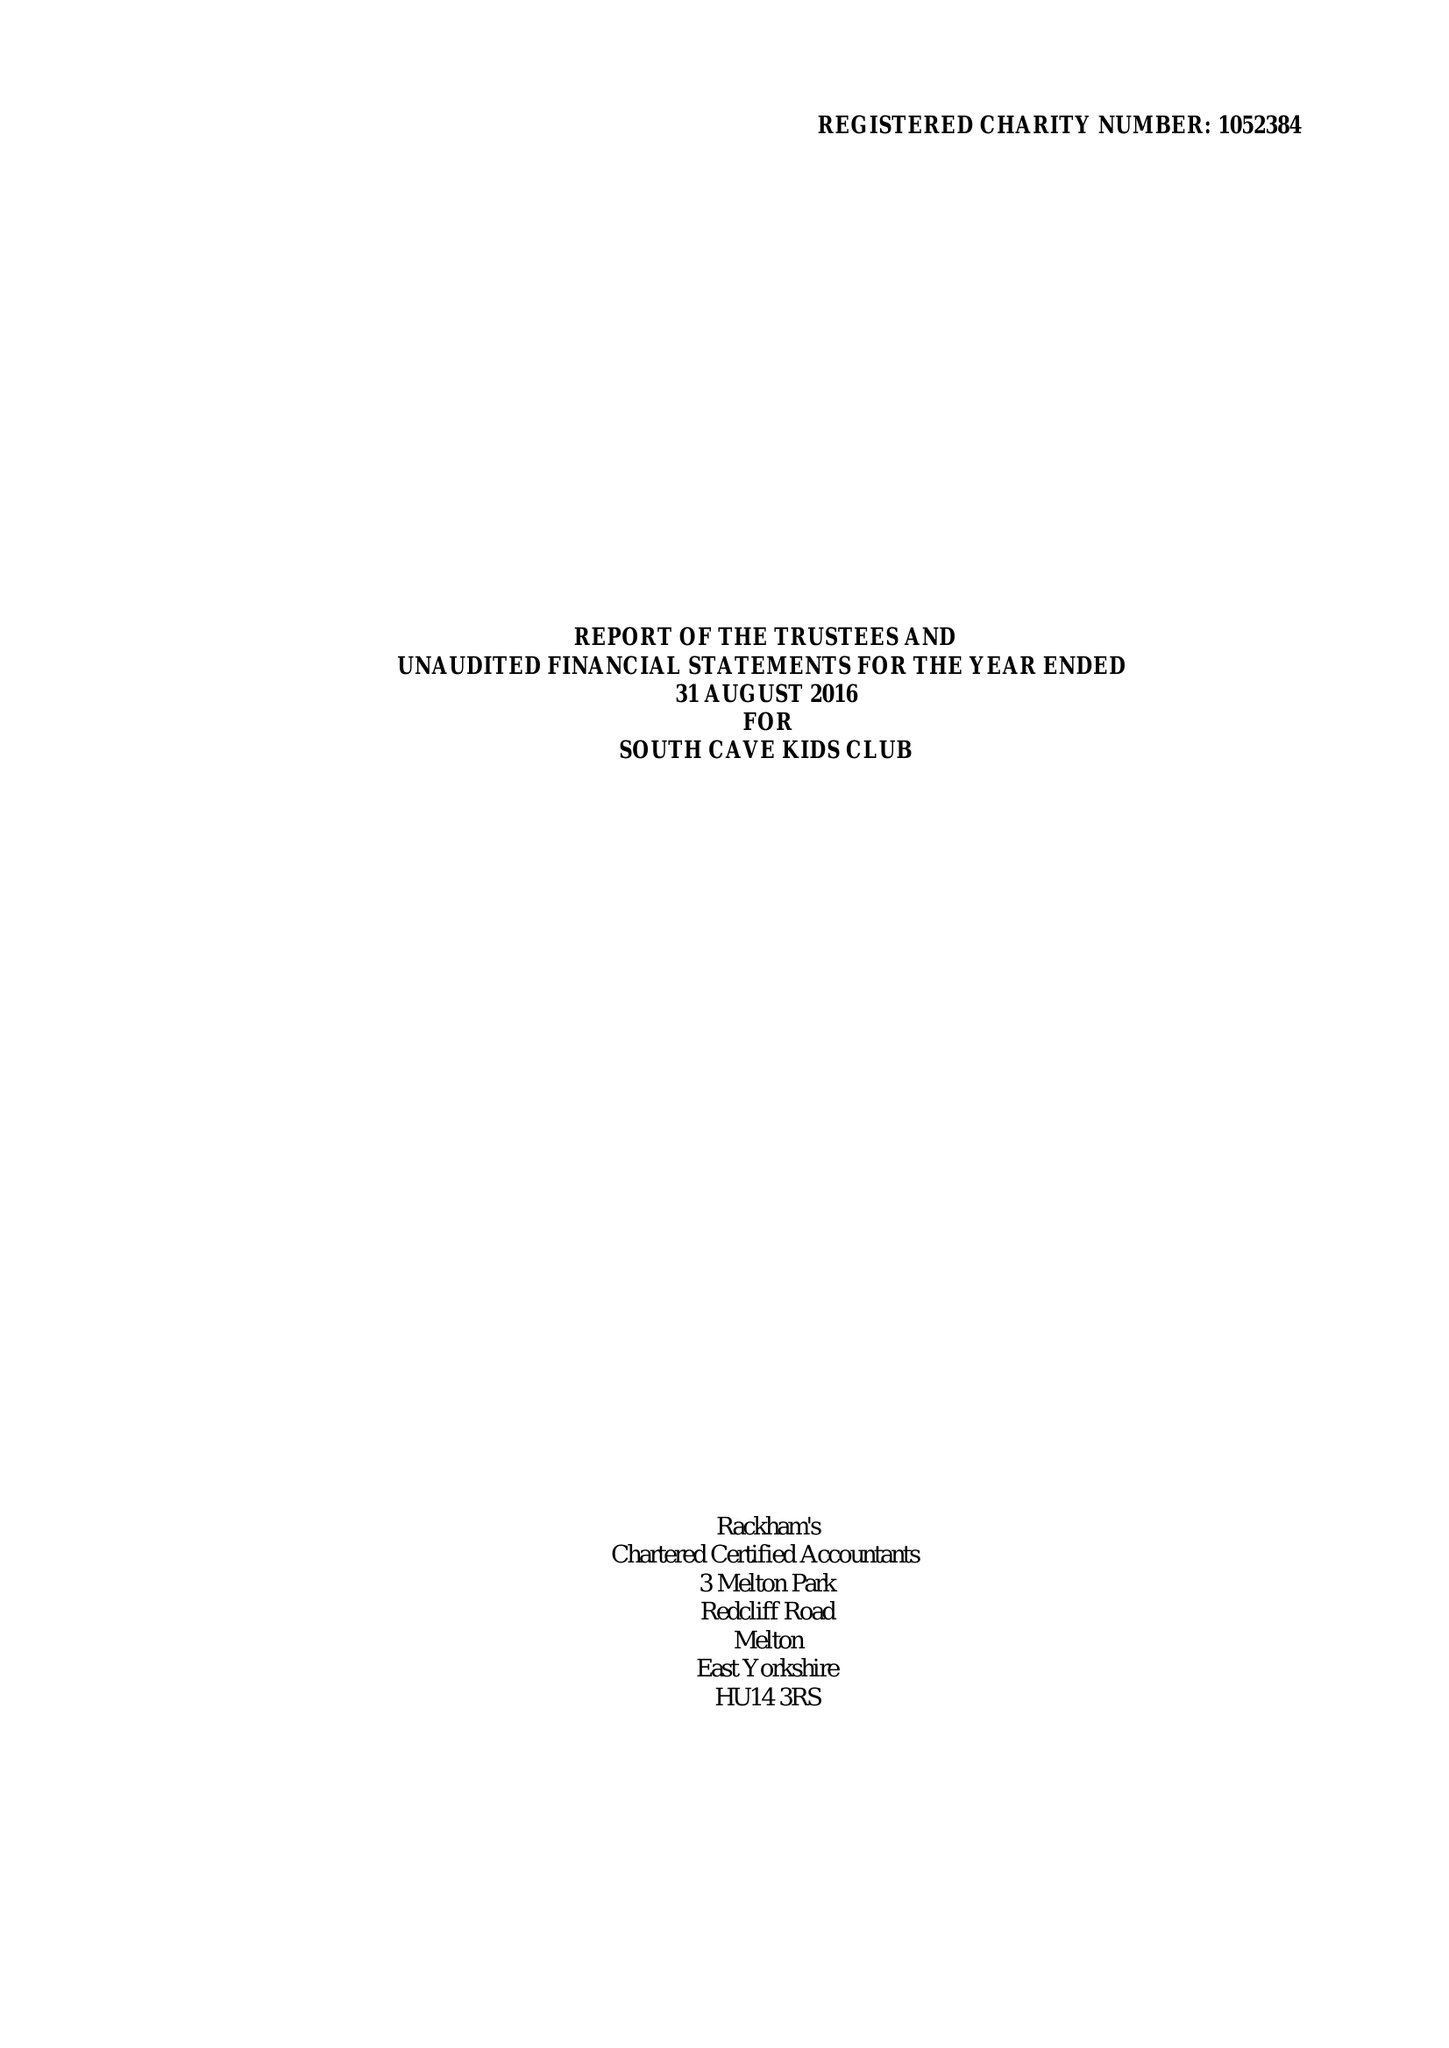What is the value for the address__street_line?
Answer the question using a single word or phrase. CHURCH STREET 